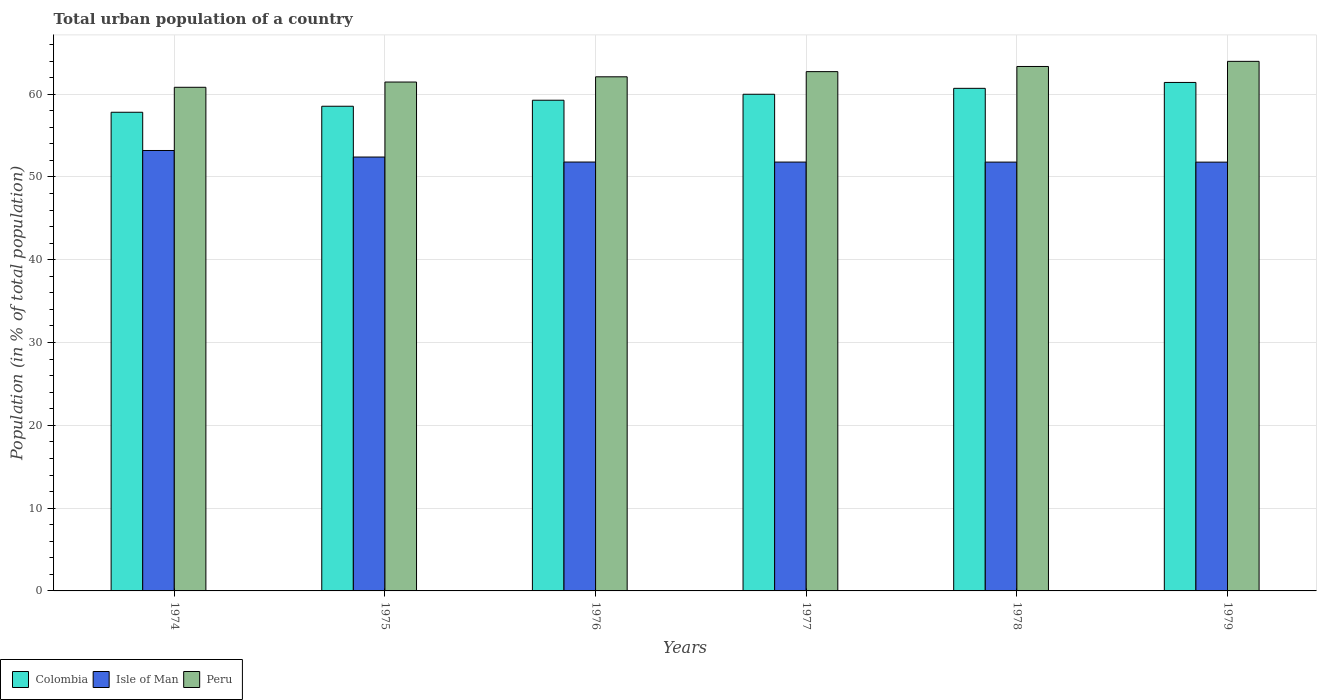How many groups of bars are there?
Keep it short and to the point. 6. Are the number of bars per tick equal to the number of legend labels?
Ensure brevity in your answer.  Yes. Are the number of bars on each tick of the X-axis equal?
Keep it short and to the point. Yes. What is the label of the 2nd group of bars from the left?
Make the answer very short. 1975. What is the urban population in Colombia in 1976?
Make the answer very short. 59.27. Across all years, what is the maximum urban population in Isle of Man?
Offer a terse response. 53.19. Across all years, what is the minimum urban population in Colombia?
Provide a short and direct response. 57.81. In which year was the urban population in Peru maximum?
Your response must be concise. 1979. In which year was the urban population in Colombia minimum?
Your response must be concise. 1974. What is the total urban population in Colombia in the graph?
Your answer should be very brief. 357.71. What is the difference between the urban population in Peru in 1975 and that in 1979?
Your answer should be compact. -2.5. What is the difference between the urban population in Isle of Man in 1976 and the urban population in Peru in 1979?
Keep it short and to the point. -12.16. What is the average urban population in Colombia per year?
Provide a succinct answer. 59.62. In the year 1974, what is the difference between the urban population in Colombia and urban population in Peru?
Keep it short and to the point. -3.02. What is the ratio of the urban population in Isle of Man in 1975 to that in 1976?
Your answer should be very brief. 1.01. What is the difference between the highest and the second highest urban population in Colombia?
Keep it short and to the point. 0.71. What is the difference between the highest and the lowest urban population in Isle of Man?
Make the answer very short. 1.41. In how many years, is the urban population in Isle of Man greater than the average urban population in Isle of Man taken over all years?
Give a very brief answer. 2. What does the 1st bar from the left in 1979 represents?
Give a very brief answer. Colombia. Is it the case that in every year, the sum of the urban population in Isle of Man and urban population in Colombia is greater than the urban population in Peru?
Ensure brevity in your answer.  Yes. How many bars are there?
Make the answer very short. 18. Are all the bars in the graph horizontal?
Provide a succinct answer. No. How many years are there in the graph?
Your answer should be compact. 6. Are the values on the major ticks of Y-axis written in scientific E-notation?
Your answer should be compact. No. How many legend labels are there?
Offer a terse response. 3. How are the legend labels stacked?
Offer a terse response. Horizontal. What is the title of the graph?
Your answer should be compact. Total urban population of a country. Does "Greece" appear as one of the legend labels in the graph?
Give a very brief answer. No. What is the label or title of the X-axis?
Keep it short and to the point. Years. What is the label or title of the Y-axis?
Your response must be concise. Population (in % of total population). What is the Population (in % of total population) of Colombia in 1974?
Your answer should be very brief. 57.81. What is the Population (in % of total population) of Isle of Man in 1974?
Your response must be concise. 53.19. What is the Population (in % of total population) of Peru in 1974?
Provide a succinct answer. 60.83. What is the Population (in % of total population) of Colombia in 1975?
Offer a very short reply. 58.54. What is the Population (in % of total population) in Isle of Man in 1975?
Make the answer very short. 52.4. What is the Population (in % of total population) in Peru in 1975?
Provide a short and direct response. 61.46. What is the Population (in % of total population) of Colombia in 1976?
Provide a short and direct response. 59.27. What is the Population (in % of total population) in Isle of Man in 1976?
Give a very brief answer. 51.8. What is the Population (in % of total population) of Peru in 1976?
Offer a terse response. 62.09. What is the Population (in % of total population) in Colombia in 1977?
Offer a terse response. 59.98. What is the Population (in % of total population) in Isle of Man in 1977?
Offer a very short reply. 51.8. What is the Population (in % of total population) in Peru in 1977?
Give a very brief answer. 62.72. What is the Population (in % of total population) of Colombia in 1978?
Ensure brevity in your answer.  60.7. What is the Population (in % of total population) in Isle of Man in 1978?
Your response must be concise. 51.79. What is the Population (in % of total population) of Peru in 1978?
Your response must be concise. 63.34. What is the Population (in % of total population) in Colombia in 1979?
Keep it short and to the point. 61.41. What is the Population (in % of total population) in Isle of Man in 1979?
Provide a short and direct response. 51.79. What is the Population (in % of total population) in Peru in 1979?
Offer a terse response. 63.96. Across all years, what is the maximum Population (in % of total population) in Colombia?
Give a very brief answer. 61.41. Across all years, what is the maximum Population (in % of total population) of Isle of Man?
Your answer should be very brief. 53.19. Across all years, what is the maximum Population (in % of total population) in Peru?
Give a very brief answer. 63.96. Across all years, what is the minimum Population (in % of total population) in Colombia?
Your response must be concise. 57.81. Across all years, what is the minimum Population (in % of total population) in Isle of Man?
Your response must be concise. 51.79. Across all years, what is the minimum Population (in % of total population) in Peru?
Offer a terse response. 60.83. What is the total Population (in % of total population) in Colombia in the graph?
Make the answer very short. 357.71. What is the total Population (in % of total population) of Isle of Man in the graph?
Offer a terse response. 312.77. What is the total Population (in % of total population) in Peru in the graph?
Give a very brief answer. 374.4. What is the difference between the Population (in % of total population) in Colombia in 1974 and that in 1975?
Provide a succinct answer. -0.73. What is the difference between the Population (in % of total population) in Isle of Man in 1974 and that in 1975?
Offer a terse response. 0.79. What is the difference between the Population (in % of total population) of Peru in 1974 and that in 1975?
Keep it short and to the point. -0.63. What is the difference between the Population (in % of total population) in Colombia in 1974 and that in 1976?
Provide a short and direct response. -1.45. What is the difference between the Population (in % of total population) of Isle of Man in 1974 and that in 1976?
Your answer should be compact. 1.4. What is the difference between the Population (in % of total population) of Peru in 1974 and that in 1976?
Offer a very short reply. -1.27. What is the difference between the Population (in % of total population) in Colombia in 1974 and that in 1977?
Provide a short and direct response. -2.17. What is the difference between the Population (in % of total population) of Isle of Man in 1974 and that in 1977?
Keep it short and to the point. 1.4. What is the difference between the Population (in % of total population) of Peru in 1974 and that in 1977?
Keep it short and to the point. -1.89. What is the difference between the Population (in % of total population) of Colombia in 1974 and that in 1978?
Your answer should be very brief. -2.89. What is the difference between the Population (in % of total population) in Isle of Man in 1974 and that in 1978?
Give a very brief answer. 1.4. What is the difference between the Population (in % of total population) of Peru in 1974 and that in 1978?
Provide a short and direct response. -2.51. What is the difference between the Population (in % of total population) in Colombia in 1974 and that in 1979?
Your answer should be very brief. -3.6. What is the difference between the Population (in % of total population) of Isle of Man in 1974 and that in 1979?
Ensure brevity in your answer.  1.41. What is the difference between the Population (in % of total population) of Peru in 1974 and that in 1979?
Make the answer very short. -3.13. What is the difference between the Population (in % of total population) of Colombia in 1975 and that in 1976?
Provide a short and direct response. -0.73. What is the difference between the Population (in % of total population) of Isle of Man in 1975 and that in 1976?
Provide a succinct answer. 0.6. What is the difference between the Population (in % of total population) in Peru in 1975 and that in 1976?
Provide a succinct answer. -0.63. What is the difference between the Population (in % of total population) in Colombia in 1975 and that in 1977?
Provide a short and direct response. -1.45. What is the difference between the Population (in % of total population) of Isle of Man in 1975 and that in 1977?
Your answer should be very brief. 0.61. What is the difference between the Population (in % of total population) in Peru in 1975 and that in 1977?
Give a very brief answer. -1.26. What is the difference between the Population (in % of total population) of Colombia in 1975 and that in 1978?
Offer a terse response. -2.16. What is the difference between the Population (in % of total population) in Isle of Man in 1975 and that in 1978?
Provide a short and direct response. 0.61. What is the difference between the Population (in % of total population) of Peru in 1975 and that in 1978?
Your answer should be very brief. -1.88. What is the difference between the Population (in % of total population) of Colombia in 1975 and that in 1979?
Ensure brevity in your answer.  -2.87. What is the difference between the Population (in % of total population) of Isle of Man in 1975 and that in 1979?
Your answer should be very brief. 0.61. What is the difference between the Population (in % of total population) of Peru in 1975 and that in 1979?
Provide a short and direct response. -2.5. What is the difference between the Population (in % of total population) of Colombia in 1976 and that in 1977?
Ensure brevity in your answer.  -0.72. What is the difference between the Population (in % of total population) of Isle of Man in 1976 and that in 1977?
Keep it short and to the point. 0. What is the difference between the Population (in % of total population) of Peru in 1976 and that in 1977?
Ensure brevity in your answer.  -0.63. What is the difference between the Population (in % of total population) of Colombia in 1976 and that in 1978?
Ensure brevity in your answer.  -1.44. What is the difference between the Population (in % of total population) of Isle of Man in 1976 and that in 1978?
Your answer should be compact. 0.01. What is the difference between the Population (in % of total population) of Peru in 1976 and that in 1978?
Provide a succinct answer. -1.25. What is the difference between the Population (in % of total population) in Colombia in 1976 and that in 1979?
Offer a very short reply. -2.15. What is the difference between the Population (in % of total population) in Isle of Man in 1976 and that in 1979?
Your response must be concise. 0.01. What is the difference between the Population (in % of total population) in Peru in 1976 and that in 1979?
Offer a very short reply. -1.87. What is the difference between the Population (in % of total population) of Colombia in 1977 and that in 1978?
Make the answer very short. -0.72. What is the difference between the Population (in % of total population) in Isle of Man in 1977 and that in 1978?
Your answer should be compact. 0. What is the difference between the Population (in % of total population) in Peru in 1977 and that in 1978?
Give a very brief answer. -0.62. What is the difference between the Population (in % of total population) of Colombia in 1977 and that in 1979?
Offer a terse response. -1.43. What is the difference between the Population (in % of total population) in Isle of Man in 1977 and that in 1979?
Keep it short and to the point. 0.01. What is the difference between the Population (in % of total population) of Peru in 1977 and that in 1979?
Keep it short and to the point. -1.24. What is the difference between the Population (in % of total population) of Colombia in 1978 and that in 1979?
Your answer should be very brief. -0.71. What is the difference between the Population (in % of total population) of Isle of Man in 1978 and that in 1979?
Your answer should be compact. 0. What is the difference between the Population (in % of total population) in Peru in 1978 and that in 1979?
Your response must be concise. -0.62. What is the difference between the Population (in % of total population) in Colombia in 1974 and the Population (in % of total population) in Isle of Man in 1975?
Make the answer very short. 5.41. What is the difference between the Population (in % of total population) of Colombia in 1974 and the Population (in % of total population) of Peru in 1975?
Keep it short and to the point. -3.65. What is the difference between the Population (in % of total population) in Isle of Man in 1974 and the Population (in % of total population) in Peru in 1975?
Offer a terse response. -8.27. What is the difference between the Population (in % of total population) of Colombia in 1974 and the Population (in % of total population) of Isle of Man in 1976?
Make the answer very short. 6.01. What is the difference between the Population (in % of total population) in Colombia in 1974 and the Population (in % of total population) in Peru in 1976?
Ensure brevity in your answer.  -4.28. What is the difference between the Population (in % of total population) in Isle of Man in 1974 and the Population (in % of total population) in Peru in 1976?
Give a very brief answer. -8.9. What is the difference between the Population (in % of total population) of Colombia in 1974 and the Population (in % of total population) of Isle of Man in 1977?
Your answer should be compact. 6.02. What is the difference between the Population (in % of total population) in Colombia in 1974 and the Population (in % of total population) in Peru in 1977?
Ensure brevity in your answer.  -4.91. What is the difference between the Population (in % of total population) in Isle of Man in 1974 and the Population (in % of total population) in Peru in 1977?
Give a very brief answer. -9.53. What is the difference between the Population (in % of total population) of Colombia in 1974 and the Population (in % of total population) of Isle of Man in 1978?
Provide a succinct answer. 6.02. What is the difference between the Population (in % of total population) of Colombia in 1974 and the Population (in % of total population) of Peru in 1978?
Offer a terse response. -5.53. What is the difference between the Population (in % of total population) in Isle of Man in 1974 and the Population (in % of total population) in Peru in 1978?
Offer a very short reply. -10.15. What is the difference between the Population (in % of total population) in Colombia in 1974 and the Population (in % of total population) in Isle of Man in 1979?
Offer a terse response. 6.02. What is the difference between the Population (in % of total population) in Colombia in 1974 and the Population (in % of total population) in Peru in 1979?
Keep it short and to the point. -6.15. What is the difference between the Population (in % of total population) of Isle of Man in 1974 and the Population (in % of total population) of Peru in 1979?
Provide a succinct answer. -10.77. What is the difference between the Population (in % of total population) of Colombia in 1975 and the Population (in % of total population) of Isle of Man in 1976?
Offer a very short reply. 6.74. What is the difference between the Population (in % of total population) of Colombia in 1975 and the Population (in % of total population) of Peru in 1976?
Ensure brevity in your answer.  -3.55. What is the difference between the Population (in % of total population) in Isle of Man in 1975 and the Population (in % of total population) in Peru in 1976?
Ensure brevity in your answer.  -9.69. What is the difference between the Population (in % of total population) of Colombia in 1975 and the Population (in % of total population) of Isle of Man in 1977?
Give a very brief answer. 6.74. What is the difference between the Population (in % of total population) in Colombia in 1975 and the Population (in % of total population) in Peru in 1977?
Offer a terse response. -4.18. What is the difference between the Population (in % of total population) in Isle of Man in 1975 and the Population (in % of total population) in Peru in 1977?
Offer a very short reply. -10.32. What is the difference between the Population (in % of total population) of Colombia in 1975 and the Population (in % of total population) of Isle of Man in 1978?
Ensure brevity in your answer.  6.75. What is the difference between the Population (in % of total population) of Colombia in 1975 and the Population (in % of total population) of Peru in 1978?
Your answer should be compact. -4.8. What is the difference between the Population (in % of total population) of Isle of Man in 1975 and the Population (in % of total population) of Peru in 1978?
Keep it short and to the point. -10.94. What is the difference between the Population (in % of total population) of Colombia in 1975 and the Population (in % of total population) of Isle of Man in 1979?
Offer a very short reply. 6.75. What is the difference between the Population (in % of total population) of Colombia in 1975 and the Population (in % of total population) of Peru in 1979?
Make the answer very short. -5.42. What is the difference between the Population (in % of total population) of Isle of Man in 1975 and the Population (in % of total population) of Peru in 1979?
Provide a succinct answer. -11.56. What is the difference between the Population (in % of total population) in Colombia in 1976 and the Population (in % of total population) in Isle of Man in 1977?
Offer a very short reply. 7.47. What is the difference between the Population (in % of total population) in Colombia in 1976 and the Population (in % of total population) in Peru in 1977?
Ensure brevity in your answer.  -3.45. What is the difference between the Population (in % of total population) in Isle of Man in 1976 and the Population (in % of total population) in Peru in 1977?
Your answer should be compact. -10.92. What is the difference between the Population (in % of total population) of Colombia in 1976 and the Population (in % of total population) of Isle of Man in 1978?
Offer a very short reply. 7.47. What is the difference between the Population (in % of total population) in Colombia in 1976 and the Population (in % of total population) in Peru in 1978?
Offer a very short reply. -4.08. What is the difference between the Population (in % of total population) of Isle of Man in 1976 and the Population (in % of total population) of Peru in 1978?
Provide a short and direct response. -11.54. What is the difference between the Population (in % of total population) in Colombia in 1976 and the Population (in % of total population) in Isle of Man in 1979?
Give a very brief answer. 7.48. What is the difference between the Population (in % of total population) in Colombia in 1976 and the Population (in % of total population) in Peru in 1979?
Your response must be concise. -4.7. What is the difference between the Population (in % of total population) of Isle of Man in 1976 and the Population (in % of total population) of Peru in 1979?
Provide a short and direct response. -12.16. What is the difference between the Population (in % of total population) of Colombia in 1977 and the Population (in % of total population) of Isle of Man in 1978?
Provide a succinct answer. 8.19. What is the difference between the Population (in % of total population) in Colombia in 1977 and the Population (in % of total population) in Peru in 1978?
Your answer should be very brief. -3.36. What is the difference between the Population (in % of total population) of Isle of Man in 1977 and the Population (in % of total population) of Peru in 1978?
Your answer should be compact. -11.55. What is the difference between the Population (in % of total population) of Colombia in 1977 and the Population (in % of total population) of Isle of Man in 1979?
Make the answer very short. 8.2. What is the difference between the Population (in % of total population) of Colombia in 1977 and the Population (in % of total population) of Peru in 1979?
Keep it short and to the point. -3.98. What is the difference between the Population (in % of total population) in Isle of Man in 1977 and the Population (in % of total population) in Peru in 1979?
Offer a very short reply. -12.16. What is the difference between the Population (in % of total population) of Colombia in 1978 and the Population (in % of total population) of Isle of Man in 1979?
Ensure brevity in your answer.  8.91. What is the difference between the Population (in % of total population) of Colombia in 1978 and the Population (in % of total population) of Peru in 1979?
Give a very brief answer. -3.26. What is the difference between the Population (in % of total population) in Isle of Man in 1978 and the Population (in % of total population) in Peru in 1979?
Provide a short and direct response. -12.17. What is the average Population (in % of total population) of Colombia per year?
Make the answer very short. 59.62. What is the average Population (in % of total population) in Isle of Man per year?
Your answer should be compact. 52.13. What is the average Population (in % of total population) in Peru per year?
Offer a very short reply. 62.4. In the year 1974, what is the difference between the Population (in % of total population) in Colombia and Population (in % of total population) in Isle of Man?
Keep it short and to the point. 4.62. In the year 1974, what is the difference between the Population (in % of total population) in Colombia and Population (in % of total population) in Peru?
Offer a terse response. -3.02. In the year 1974, what is the difference between the Population (in % of total population) of Isle of Man and Population (in % of total population) of Peru?
Give a very brief answer. -7.63. In the year 1975, what is the difference between the Population (in % of total population) of Colombia and Population (in % of total population) of Isle of Man?
Provide a succinct answer. 6.14. In the year 1975, what is the difference between the Population (in % of total population) in Colombia and Population (in % of total population) in Peru?
Provide a short and direct response. -2.92. In the year 1975, what is the difference between the Population (in % of total population) in Isle of Man and Population (in % of total population) in Peru?
Offer a terse response. -9.06. In the year 1976, what is the difference between the Population (in % of total population) in Colombia and Population (in % of total population) in Isle of Man?
Your answer should be very brief. 7.47. In the year 1976, what is the difference between the Population (in % of total population) of Colombia and Population (in % of total population) of Peru?
Provide a short and direct response. -2.83. In the year 1976, what is the difference between the Population (in % of total population) in Isle of Man and Population (in % of total population) in Peru?
Offer a terse response. -10.29. In the year 1977, what is the difference between the Population (in % of total population) in Colombia and Population (in % of total population) in Isle of Man?
Ensure brevity in your answer.  8.19. In the year 1977, what is the difference between the Population (in % of total population) in Colombia and Population (in % of total population) in Peru?
Your response must be concise. -2.73. In the year 1977, what is the difference between the Population (in % of total population) in Isle of Man and Population (in % of total population) in Peru?
Keep it short and to the point. -10.92. In the year 1978, what is the difference between the Population (in % of total population) in Colombia and Population (in % of total population) in Isle of Man?
Ensure brevity in your answer.  8.91. In the year 1978, what is the difference between the Population (in % of total population) of Colombia and Population (in % of total population) of Peru?
Provide a short and direct response. -2.64. In the year 1978, what is the difference between the Population (in % of total population) of Isle of Man and Population (in % of total population) of Peru?
Offer a very short reply. -11.55. In the year 1979, what is the difference between the Population (in % of total population) of Colombia and Population (in % of total population) of Isle of Man?
Offer a very short reply. 9.62. In the year 1979, what is the difference between the Population (in % of total population) of Colombia and Population (in % of total population) of Peru?
Ensure brevity in your answer.  -2.55. In the year 1979, what is the difference between the Population (in % of total population) of Isle of Man and Population (in % of total population) of Peru?
Make the answer very short. -12.17. What is the ratio of the Population (in % of total population) of Colombia in 1974 to that in 1975?
Your answer should be compact. 0.99. What is the ratio of the Population (in % of total population) of Isle of Man in 1974 to that in 1975?
Provide a short and direct response. 1.02. What is the ratio of the Population (in % of total population) of Colombia in 1974 to that in 1976?
Give a very brief answer. 0.98. What is the ratio of the Population (in % of total population) in Isle of Man in 1974 to that in 1976?
Provide a succinct answer. 1.03. What is the ratio of the Population (in % of total population) in Peru in 1974 to that in 1976?
Provide a succinct answer. 0.98. What is the ratio of the Population (in % of total population) in Colombia in 1974 to that in 1977?
Your answer should be very brief. 0.96. What is the ratio of the Population (in % of total population) in Isle of Man in 1974 to that in 1977?
Make the answer very short. 1.03. What is the ratio of the Population (in % of total population) of Peru in 1974 to that in 1977?
Give a very brief answer. 0.97. What is the ratio of the Population (in % of total population) of Isle of Man in 1974 to that in 1978?
Give a very brief answer. 1.03. What is the ratio of the Population (in % of total population) of Peru in 1974 to that in 1978?
Your answer should be compact. 0.96. What is the ratio of the Population (in % of total population) of Colombia in 1974 to that in 1979?
Your answer should be very brief. 0.94. What is the ratio of the Population (in % of total population) of Isle of Man in 1974 to that in 1979?
Give a very brief answer. 1.03. What is the ratio of the Population (in % of total population) in Peru in 1974 to that in 1979?
Provide a short and direct response. 0.95. What is the ratio of the Population (in % of total population) of Isle of Man in 1975 to that in 1976?
Offer a very short reply. 1.01. What is the ratio of the Population (in % of total population) in Peru in 1975 to that in 1976?
Make the answer very short. 0.99. What is the ratio of the Population (in % of total population) of Colombia in 1975 to that in 1977?
Make the answer very short. 0.98. What is the ratio of the Population (in % of total population) in Isle of Man in 1975 to that in 1977?
Make the answer very short. 1.01. What is the ratio of the Population (in % of total population) of Peru in 1975 to that in 1977?
Your answer should be very brief. 0.98. What is the ratio of the Population (in % of total population) in Colombia in 1975 to that in 1978?
Offer a very short reply. 0.96. What is the ratio of the Population (in % of total population) in Isle of Man in 1975 to that in 1978?
Your answer should be compact. 1.01. What is the ratio of the Population (in % of total population) of Peru in 1975 to that in 1978?
Offer a very short reply. 0.97. What is the ratio of the Population (in % of total population) of Colombia in 1975 to that in 1979?
Your answer should be very brief. 0.95. What is the ratio of the Population (in % of total population) of Isle of Man in 1975 to that in 1979?
Give a very brief answer. 1.01. What is the ratio of the Population (in % of total population) of Peru in 1975 to that in 1979?
Your response must be concise. 0.96. What is the ratio of the Population (in % of total population) in Isle of Man in 1976 to that in 1977?
Offer a very short reply. 1. What is the ratio of the Population (in % of total population) of Peru in 1976 to that in 1977?
Your response must be concise. 0.99. What is the ratio of the Population (in % of total population) of Colombia in 1976 to that in 1978?
Your answer should be compact. 0.98. What is the ratio of the Population (in % of total population) of Isle of Man in 1976 to that in 1978?
Your response must be concise. 1. What is the ratio of the Population (in % of total population) of Peru in 1976 to that in 1978?
Your answer should be compact. 0.98. What is the ratio of the Population (in % of total population) of Colombia in 1976 to that in 1979?
Your answer should be compact. 0.96. What is the ratio of the Population (in % of total population) of Isle of Man in 1976 to that in 1979?
Your answer should be compact. 1. What is the ratio of the Population (in % of total population) in Peru in 1976 to that in 1979?
Your answer should be very brief. 0.97. What is the ratio of the Population (in % of total population) in Colombia in 1977 to that in 1978?
Keep it short and to the point. 0.99. What is the ratio of the Population (in % of total population) in Peru in 1977 to that in 1978?
Provide a succinct answer. 0.99. What is the ratio of the Population (in % of total population) of Colombia in 1977 to that in 1979?
Offer a terse response. 0.98. What is the ratio of the Population (in % of total population) in Peru in 1977 to that in 1979?
Your response must be concise. 0.98. What is the ratio of the Population (in % of total population) in Colombia in 1978 to that in 1979?
Your response must be concise. 0.99. What is the ratio of the Population (in % of total population) of Isle of Man in 1978 to that in 1979?
Offer a very short reply. 1. What is the ratio of the Population (in % of total population) in Peru in 1978 to that in 1979?
Ensure brevity in your answer.  0.99. What is the difference between the highest and the second highest Population (in % of total population) of Colombia?
Make the answer very short. 0.71. What is the difference between the highest and the second highest Population (in % of total population) of Isle of Man?
Your answer should be very brief. 0.79. What is the difference between the highest and the second highest Population (in % of total population) of Peru?
Your answer should be very brief. 0.62. What is the difference between the highest and the lowest Population (in % of total population) in Colombia?
Provide a succinct answer. 3.6. What is the difference between the highest and the lowest Population (in % of total population) of Isle of Man?
Offer a terse response. 1.41. What is the difference between the highest and the lowest Population (in % of total population) in Peru?
Your response must be concise. 3.13. 